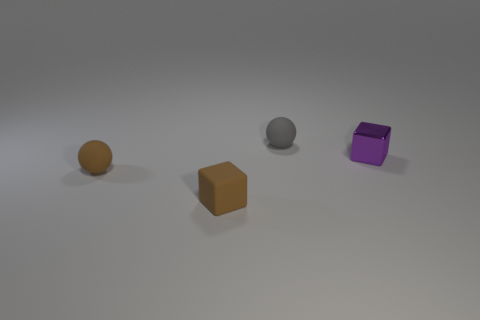Add 3 gray rubber cylinders. How many objects exist? 7 Subtract 0 cyan cylinders. How many objects are left? 4 Subtract all tiny purple things. Subtract all tiny purple shiny blocks. How many objects are left? 2 Add 3 brown balls. How many brown balls are left? 4 Add 3 blue rubber things. How many blue rubber things exist? 3 